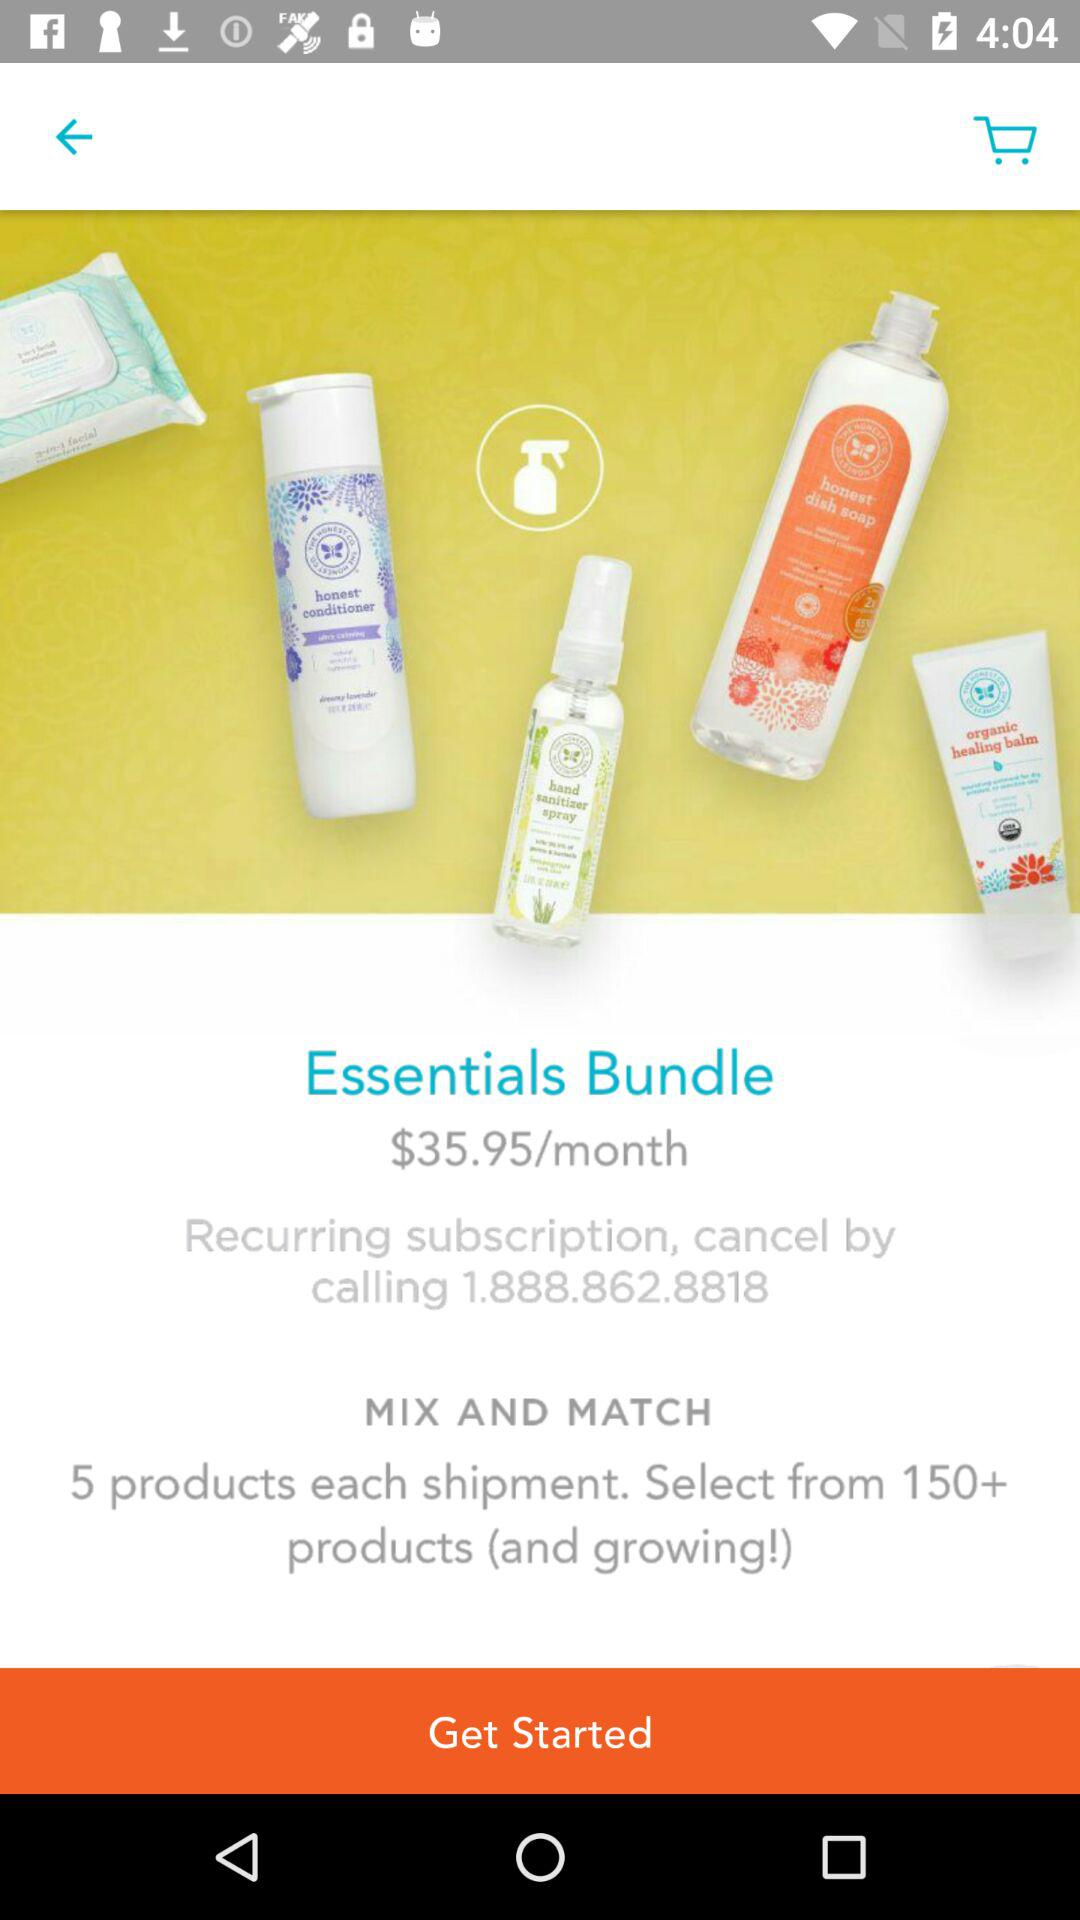How many products in total are there? There are more than 150 products in total. 